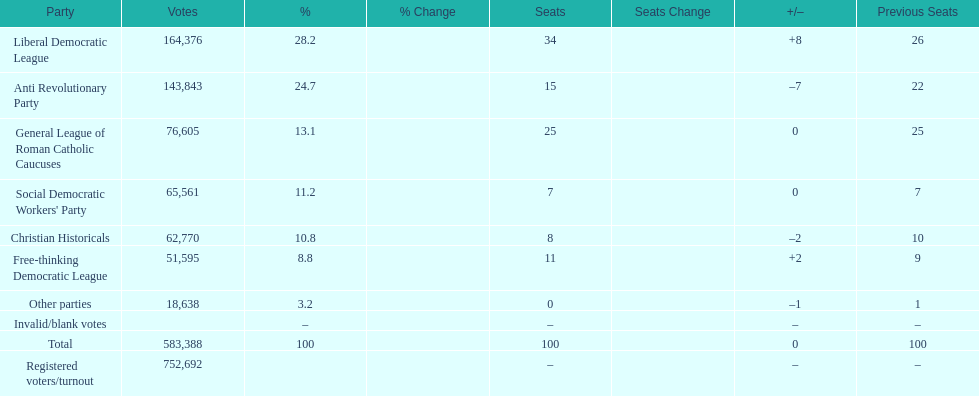Can you parse all the data within this table? {'header': ['Party', 'Votes', '%', '% Change', 'Seats', 'Seats Change', '+/–', 'Previous Seats'], 'rows': [['Liberal Democratic League', '164,376', '28.2', '', '34', '', '+8', '26'], ['Anti Revolutionary Party', '143,843', '24.7', '', '15', '', '–7', '22'], ['General League of Roman Catholic Caucuses', '76,605', '13.1', '', '25', '', '0', '25'], ["Social Democratic Workers' Party", '65,561', '11.2', '', '7', '', '0', '7'], ['Christian Historicals', '62,770', '10.8', '', '8', '', '–2', '10'], ['Free-thinking Democratic League', '51,595', '8.8', '', '11', '', '+2', '9'], ['Other parties', '18,638', '3.2', '', '0', '', '–1', '1'], ['Invalid/blank votes', '', '–', '', '–', '', '–', '–'], ['Total', '583,388', '100', '', '100', '', '0', '100'], ['Registered voters/turnout', '752,692', '', '', '–', '', '–', '–']]} How many votes were counted as invalid or blank votes? 0. 